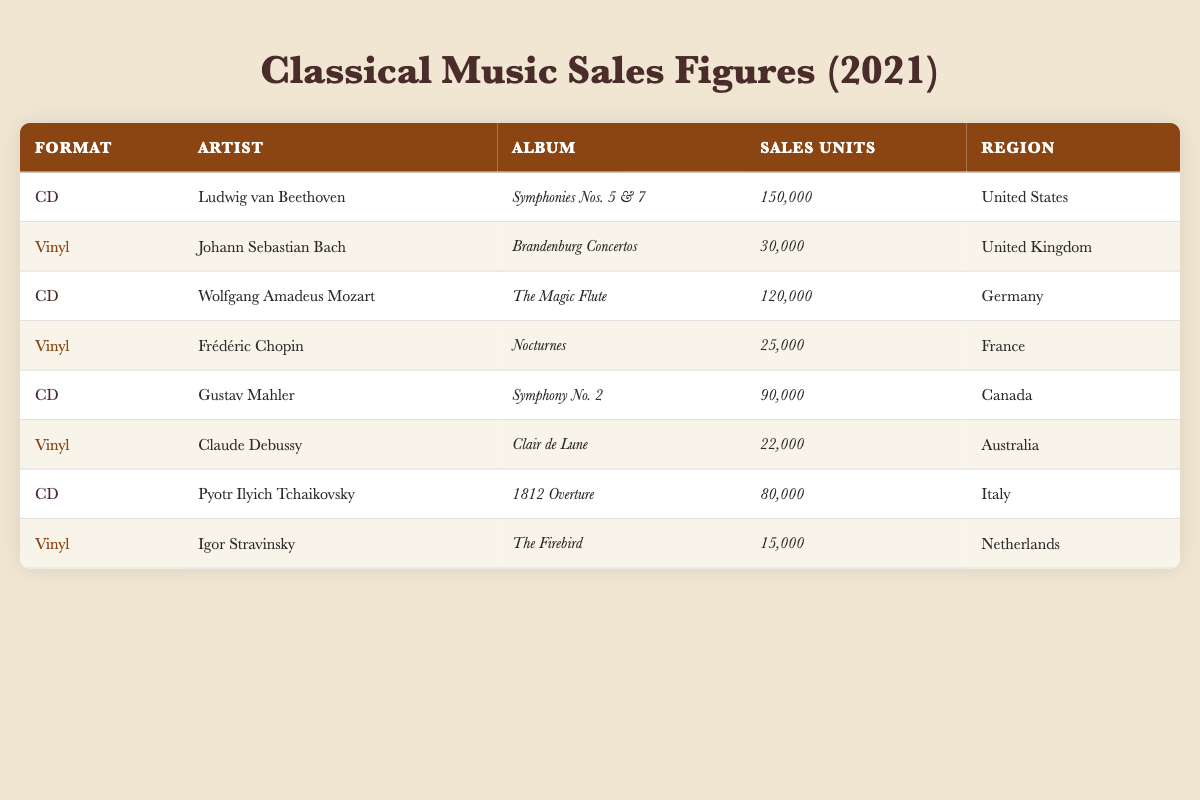What is the total number of CD sales in the United States? There is one entry for CD sales in the United States, which shows sales of 150,000 units for Beethoven's album. Thus, the total for the United States is simply 150,000.
Answer: 150,000 Which album sold the most units in 2021? Beethoven's "Symphonies Nos. 5 & 7" is the only entry with sales of 150,000 units, which is higher than any other album listed.
Answer: "Symphonies Nos. 5 & 7" How many units were sold for the Bach and Chopin albums combined? For the Bach album "Brandenburg Concertos," 30,000 units were sold, and for Chopin's "Nocturnes," 25,000 units were sold. Adding these gives 30,000 + 25,000 = 55,000.
Answer: 55,000 Which region had the highest sales of vinyl records? The UK had the highest sales of vinyl records with 30,000 units sold for Bach's album. In comparison, all other regions had lower sales figures for vinyl.
Answer: United Kingdom Did any album sell more vinyl records than the album "The Firebird"? "The Firebird" sold 15,000 vinyl records. The only album with higher sales is Bach's "Brandenburg Concertos" at 30,000 and Chopin's "Nocturnes" at 25,000, meaning there are two albums that sold more than "The Firebird."
Answer: Yes What was the average sales of CDs across all listed albums? To calculate the average, sum the CD sales: 150,000 + 120,000 + 90,000 + 80,000 = 440,000. There are four CD albums, so the average is 440,000 / 4 = 110,000.
Answer: 110,000 How many more vinyl records were sold in the UK compared to Australia? The UK had 30,000 vinyl sales, while Australia had 22,000. To find the difference, subtract 22,000 from 30,000, which equals 8,000.
Answer: 8,000 Which artist had the lowest sales, and how many units did they sell? Igor Stravinsky's "The Firebird" had the lowest sales with 15,000 units. This is confirmed by comparing all artists' album sales.
Answer: Igor Stravinsky; 15,000 If you combine all sales units from both formats, how many units were sold in Canada? For Canada, only Mahler's CD "Symphony No. 2" is listed with sales of 90,000 units. Therefore, the total sales in Canada remain 90,000 as there are no vinyl records listed.
Answer: 90,000 Which format generally had higher sales in 2021, CD or Vinyl? Total the sales for CDs: 150,000 + 120,000 + 90,000 + 80,000 = 440,000. Total the sales for vinyls: 30,000 + 25,000 + 22,000 + 15,000 = 92,000. The CDs far exceed the vinyl sales.
Answer: CD Were there any vinyl albums that sold over 20,000 units? Yes, the albums by Bach (30,000) and Chopin (25,000) both sold over 20,000 units, while Debussy (22,000) also surpassed that mark.
Answer: Yes 